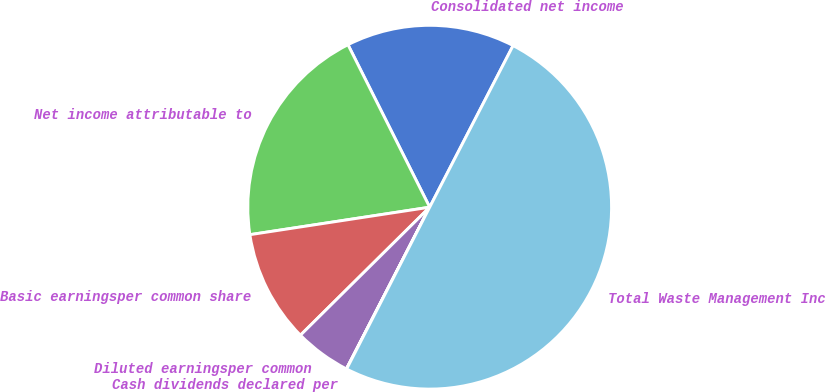<chart> <loc_0><loc_0><loc_500><loc_500><pie_chart><fcel>Consolidated net income<fcel>Net income attributable to<fcel>Basic earningsper common share<fcel>Diluted earningsper common<fcel>Cash dividends declared per<fcel>Total Waste Management Inc<nl><fcel>15.0%<fcel>20.0%<fcel>10.01%<fcel>5.01%<fcel>0.02%<fcel>49.97%<nl></chart> 